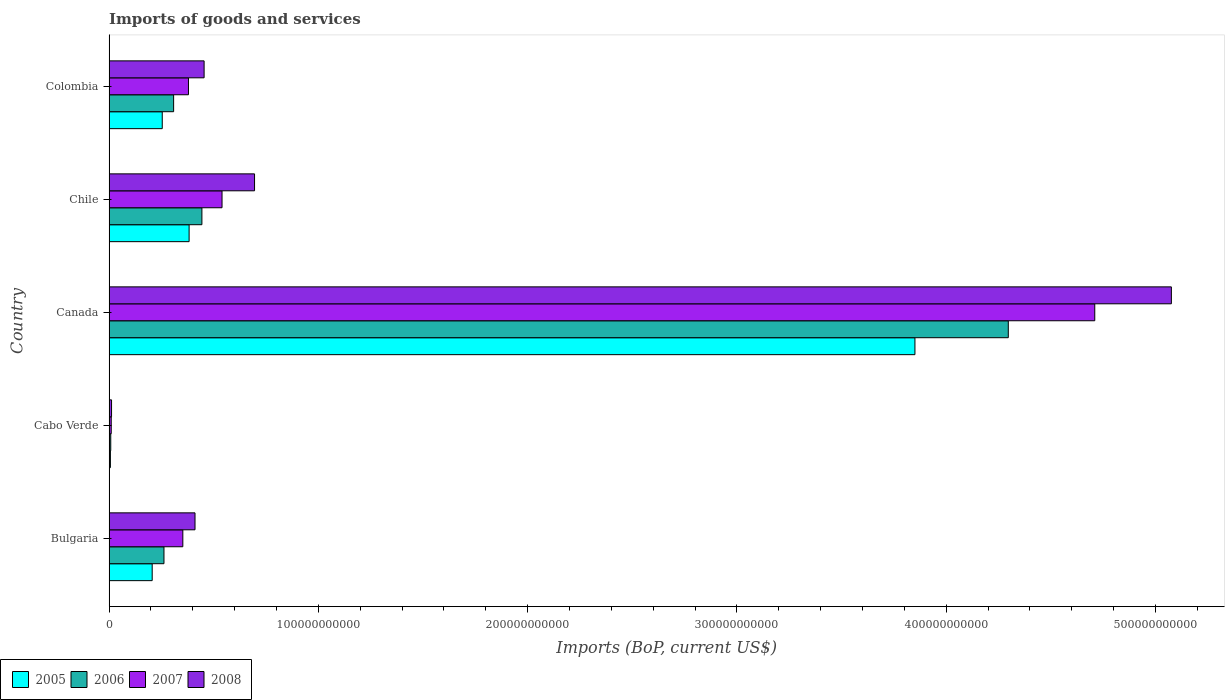How many different coloured bars are there?
Your answer should be compact. 4. How many groups of bars are there?
Your answer should be very brief. 5. Are the number of bars per tick equal to the number of legend labels?
Give a very brief answer. Yes. Are the number of bars on each tick of the Y-axis equal?
Offer a terse response. Yes. What is the label of the 4th group of bars from the top?
Offer a terse response. Cabo Verde. What is the amount spent on imports in 2007 in Canada?
Ensure brevity in your answer.  4.71e+11. Across all countries, what is the maximum amount spent on imports in 2007?
Make the answer very short. 4.71e+11. Across all countries, what is the minimum amount spent on imports in 2006?
Make the answer very short. 8.04e+08. In which country was the amount spent on imports in 2008 maximum?
Your response must be concise. Canada. In which country was the amount spent on imports in 2008 minimum?
Provide a short and direct response. Cabo Verde. What is the total amount spent on imports in 2005 in the graph?
Offer a very short reply. 4.70e+11. What is the difference between the amount spent on imports in 2006 in Bulgaria and that in Cabo Verde?
Your response must be concise. 2.54e+1. What is the difference between the amount spent on imports in 2005 in Cabo Verde and the amount spent on imports in 2007 in Colombia?
Your answer should be compact. -3.73e+1. What is the average amount spent on imports in 2007 per country?
Ensure brevity in your answer.  1.20e+11. What is the difference between the amount spent on imports in 2005 and amount spent on imports in 2007 in Canada?
Your answer should be compact. -8.59e+1. What is the ratio of the amount spent on imports in 2006 in Bulgaria to that in Cabo Verde?
Offer a very short reply. 32.64. Is the amount spent on imports in 2006 in Canada less than that in Colombia?
Keep it short and to the point. No. What is the difference between the highest and the second highest amount spent on imports in 2008?
Provide a short and direct response. 4.38e+11. What is the difference between the highest and the lowest amount spent on imports in 2006?
Give a very brief answer. 4.29e+11. Is the sum of the amount spent on imports in 2007 in Canada and Chile greater than the maximum amount spent on imports in 2008 across all countries?
Your answer should be compact. Yes. Is it the case that in every country, the sum of the amount spent on imports in 2008 and amount spent on imports in 2006 is greater than the sum of amount spent on imports in 2007 and amount spent on imports in 2005?
Ensure brevity in your answer.  No. What does the 2nd bar from the bottom in Bulgaria represents?
Make the answer very short. 2006. Is it the case that in every country, the sum of the amount spent on imports in 2006 and amount spent on imports in 2005 is greater than the amount spent on imports in 2007?
Make the answer very short. Yes. How many bars are there?
Your response must be concise. 20. How many countries are there in the graph?
Give a very brief answer. 5. What is the difference between two consecutive major ticks on the X-axis?
Give a very brief answer. 1.00e+11. Are the values on the major ticks of X-axis written in scientific E-notation?
Ensure brevity in your answer.  No. Does the graph contain any zero values?
Provide a succinct answer. No. Does the graph contain grids?
Ensure brevity in your answer.  No. Where does the legend appear in the graph?
Your answer should be very brief. Bottom left. What is the title of the graph?
Give a very brief answer. Imports of goods and services. What is the label or title of the X-axis?
Provide a short and direct response. Imports (BoP, current US$). What is the Imports (BoP, current US$) in 2005 in Bulgaria?
Offer a very short reply. 2.06e+1. What is the Imports (BoP, current US$) in 2006 in Bulgaria?
Offer a terse response. 2.62e+1. What is the Imports (BoP, current US$) of 2007 in Bulgaria?
Give a very brief answer. 3.52e+1. What is the Imports (BoP, current US$) of 2008 in Bulgaria?
Offer a terse response. 4.11e+1. What is the Imports (BoP, current US$) of 2005 in Cabo Verde?
Your response must be concise. 6.42e+08. What is the Imports (BoP, current US$) in 2006 in Cabo Verde?
Provide a succinct answer. 8.04e+08. What is the Imports (BoP, current US$) of 2007 in Cabo Verde?
Your answer should be very brief. 1.03e+09. What is the Imports (BoP, current US$) of 2008 in Cabo Verde?
Keep it short and to the point. 1.18e+09. What is the Imports (BoP, current US$) in 2005 in Canada?
Your answer should be compact. 3.85e+11. What is the Imports (BoP, current US$) in 2006 in Canada?
Provide a short and direct response. 4.30e+11. What is the Imports (BoP, current US$) in 2007 in Canada?
Your answer should be compact. 4.71e+11. What is the Imports (BoP, current US$) in 2008 in Canada?
Provide a succinct answer. 5.08e+11. What is the Imports (BoP, current US$) in 2005 in Chile?
Provide a succinct answer. 3.82e+1. What is the Imports (BoP, current US$) of 2006 in Chile?
Your answer should be compact. 4.44e+1. What is the Imports (BoP, current US$) of 2007 in Chile?
Give a very brief answer. 5.40e+1. What is the Imports (BoP, current US$) of 2008 in Chile?
Give a very brief answer. 6.95e+1. What is the Imports (BoP, current US$) in 2005 in Colombia?
Ensure brevity in your answer.  2.54e+1. What is the Imports (BoP, current US$) of 2006 in Colombia?
Your response must be concise. 3.09e+1. What is the Imports (BoP, current US$) in 2007 in Colombia?
Offer a very short reply. 3.79e+1. What is the Imports (BoP, current US$) of 2008 in Colombia?
Make the answer very short. 4.54e+1. Across all countries, what is the maximum Imports (BoP, current US$) in 2005?
Keep it short and to the point. 3.85e+11. Across all countries, what is the maximum Imports (BoP, current US$) in 2006?
Provide a succinct answer. 4.30e+11. Across all countries, what is the maximum Imports (BoP, current US$) in 2007?
Your response must be concise. 4.71e+11. Across all countries, what is the maximum Imports (BoP, current US$) in 2008?
Offer a very short reply. 5.08e+11. Across all countries, what is the minimum Imports (BoP, current US$) of 2005?
Your answer should be compact. 6.42e+08. Across all countries, what is the minimum Imports (BoP, current US$) in 2006?
Offer a very short reply. 8.04e+08. Across all countries, what is the minimum Imports (BoP, current US$) of 2007?
Offer a terse response. 1.03e+09. Across all countries, what is the minimum Imports (BoP, current US$) in 2008?
Make the answer very short. 1.18e+09. What is the total Imports (BoP, current US$) in 2005 in the graph?
Make the answer very short. 4.70e+11. What is the total Imports (BoP, current US$) of 2006 in the graph?
Your answer should be compact. 5.32e+11. What is the total Imports (BoP, current US$) in 2007 in the graph?
Offer a terse response. 5.99e+11. What is the total Imports (BoP, current US$) in 2008 in the graph?
Your response must be concise. 6.65e+11. What is the difference between the Imports (BoP, current US$) of 2005 in Bulgaria and that in Cabo Verde?
Offer a terse response. 2.00e+1. What is the difference between the Imports (BoP, current US$) in 2006 in Bulgaria and that in Cabo Verde?
Give a very brief answer. 2.54e+1. What is the difference between the Imports (BoP, current US$) in 2007 in Bulgaria and that in Cabo Verde?
Offer a very short reply. 3.42e+1. What is the difference between the Imports (BoP, current US$) in 2008 in Bulgaria and that in Cabo Verde?
Your response must be concise. 3.99e+1. What is the difference between the Imports (BoP, current US$) in 2005 in Bulgaria and that in Canada?
Your answer should be compact. -3.64e+11. What is the difference between the Imports (BoP, current US$) in 2006 in Bulgaria and that in Canada?
Give a very brief answer. -4.03e+11. What is the difference between the Imports (BoP, current US$) in 2007 in Bulgaria and that in Canada?
Offer a terse response. -4.36e+11. What is the difference between the Imports (BoP, current US$) in 2008 in Bulgaria and that in Canada?
Offer a very short reply. -4.67e+11. What is the difference between the Imports (BoP, current US$) in 2005 in Bulgaria and that in Chile?
Your answer should be very brief. -1.76e+1. What is the difference between the Imports (BoP, current US$) in 2006 in Bulgaria and that in Chile?
Make the answer very short. -1.81e+1. What is the difference between the Imports (BoP, current US$) of 2007 in Bulgaria and that in Chile?
Offer a very short reply. -1.87e+1. What is the difference between the Imports (BoP, current US$) in 2008 in Bulgaria and that in Chile?
Offer a very short reply. -2.85e+1. What is the difference between the Imports (BoP, current US$) in 2005 in Bulgaria and that in Colombia?
Provide a short and direct response. -4.80e+09. What is the difference between the Imports (BoP, current US$) in 2006 in Bulgaria and that in Colombia?
Offer a very short reply. -4.62e+09. What is the difference between the Imports (BoP, current US$) in 2007 in Bulgaria and that in Colombia?
Make the answer very short. -2.70e+09. What is the difference between the Imports (BoP, current US$) of 2008 in Bulgaria and that in Colombia?
Offer a very short reply. -4.35e+09. What is the difference between the Imports (BoP, current US$) in 2005 in Cabo Verde and that in Canada?
Offer a very short reply. -3.84e+11. What is the difference between the Imports (BoP, current US$) in 2006 in Cabo Verde and that in Canada?
Your answer should be very brief. -4.29e+11. What is the difference between the Imports (BoP, current US$) of 2007 in Cabo Verde and that in Canada?
Offer a terse response. -4.70e+11. What is the difference between the Imports (BoP, current US$) of 2008 in Cabo Verde and that in Canada?
Offer a very short reply. -5.06e+11. What is the difference between the Imports (BoP, current US$) in 2005 in Cabo Verde and that in Chile?
Your response must be concise. -3.76e+1. What is the difference between the Imports (BoP, current US$) in 2006 in Cabo Verde and that in Chile?
Keep it short and to the point. -4.36e+1. What is the difference between the Imports (BoP, current US$) of 2007 in Cabo Verde and that in Chile?
Your response must be concise. -5.29e+1. What is the difference between the Imports (BoP, current US$) in 2008 in Cabo Verde and that in Chile?
Give a very brief answer. -6.83e+1. What is the difference between the Imports (BoP, current US$) in 2005 in Cabo Verde and that in Colombia?
Your answer should be compact. -2.48e+1. What is the difference between the Imports (BoP, current US$) in 2006 in Cabo Verde and that in Colombia?
Offer a very short reply. -3.00e+1. What is the difference between the Imports (BoP, current US$) of 2007 in Cabo Verde and that in Colombia?
Keep it short and to the point. -3.69e+1. What is the difference between the Imports (BoP, current US$) in 2008 in Cabo Verde and that in Colombia?
Your answer should be compact. -4.42e+1. What is the difference between the Imports (BoP, current US$) of 2005 in Canada and that in Chile?
Give a very brief answer. 3.47e+11. What is the difference between the Imports (BoP, current US$) of 2006 in Canada and that in Chile?
Provide a succinct answer. 3.85e+11. What is the difference between the Imports (BoP, current US$) in 2007 in Canada and that in Chile?
Ensure brevity in your answer.  4.17e+11. What is the difference between the Imports (BoP, current US$) in 2008 in Canada and that in Chile?
Keep it short and to the point. 4.38e+11. What is the difference between the Imports (BoP, current US$) of 2005 in Canada and that in Colombia?
Give a very brief answer. 3.60e+11. What is the difference between the Imports (BoP, current US$) of 2006 in Canada and that in Colombia?
Provide a short and direct response. 3.99e+11. What is the difference between the Imports (BoP, current US$) of 2007 in Canada and that in Colombia?
Ensure brevity in your answer.  4.33e+11. What is the difference between the Imports (BoP, current US$) in 2008 in Canada and that in Colombia?
Ensure brevity in your answer.  4.62e+11. What is the difference between the Imports (BoP, current US$) of 2005 in Chile and that in Colombia?
Give a very brief answer. 1.28e+1. What is the difference between the Imports (BoP, current US$) in 2006 in Chile and that in Colombia?
Offer a terse response. 1.35e+1. What is the difference between the Imports (BoP, current US$) in 2007 in Chile and that in Colombia?
Provide a short and direct response. 1.60e+1. What is the difference between the Imports (BoP, current US$) of 2008 in Chile and that in Colombia?
Make the answer very short. 2.41e+1. What is the difference between the Imports (BoP, current US$) in 2005 in Bulgaria and the Imports (BoP, current US$) in 2006 in Cabo Verde?
Your answer should be compact. 1.98e+1. What is the difference between the Imports (BoP, current US$) of 2005 in Bulgaria and the Imports (BoP, current US$) of 2007 in Cabo Verde?
Your answer should be compact. 1.96e+1. What is the difference between the Imports (BoP, current US$) in 2005 in Bulgaria and the Imports (BoP, current US$) in 2008 in Cabo Verde?
Your answer should be very brief. 1.94e+1. What is the difference between the Imports (BoP, current US$) of 2006 in Bulgaria and the Imports (BoP, current US$) of 2007 in Cabo Verde?
Make the answer very short. 2.52e+1. What is the difference between the Imports (BoP, current US$) of 2006 in Bulgaria and the Imports (BoP, current US$) of 2008 in Cabo Verde?
Provide a short and direct response. 2.51e+1. What is the difference between the Imports (BoP, current US$) in 2007 in Bulgaria and the Imports (BoP, current US$) in 2008 in Cabo Verde?
Offer a very short reply. 3.41e+1. What is the difference between the Imports (BoP, current US$) in 2005 in Bulgaria and the Imports (BoP, current US$) in 2006 in Canada?
Make the answer very short. -4.09e+11. What is the difference between the Imports (BoP, current US$) of 2005 in Bulgaria and the Imports (BoP, current US$) of 2007 in Canada?
Your response must be concise. -4.50e+11. What is the difference between the Imports (BoP, current US$) of 2005 in Bulgaria and the Imports (BoP, current US$) of 2008 in Canada?
Make the answer very short. -4.87e+11. What is the difference between the Imports (BoP, current US$) of 2006 in Bulgaria and the Imports (BoP, current US$) of 2007 in Canada?
Make the answer very short. -4.45e+11. What is the difference between the Imports (BoP, current US$) in 2006 in Bulgaria and the Imports (BoP, current US$) in 2008 in Canada?
Provide a succinct answer. -4.81e+11. What is the difference between the Imports (BoP, current US$) of 2007 in Bulgaria and the Imports (BoP, current US$) of 2008 in Canada?
Ensure brevity in your answer.  -4.72e+11. What is the difference between the Imports (BoP, current US$) of 2005 in Bulgaria and the Imports (BoP, current US$) of 2006 in Chile?
Offer a very short reply. -2.38e+1. What is the difference between the Imports (BoP, current US$) of 2005 in Bulgaria and the Imports (BoP, current US$) of 2007 in Chile?
Offer a very short reply. -3.34e+1. What is the difference between the Imports (BoP, current US$) in 2005 in Bulgaria and the Imports (BoP, current US$) in 2008 in Chile?
Keep it short and to the point. -4.89e+1. What is the difference between the Imports (BoP, current US$) in 2006 in Bulgaria and the Imports (BoP, current US$) in 2007 in Chile?
Your answer should be compact. -2.77e+1. What is the difference between the Imports (BoP, current US$) in 2006 in Bulgaria and the Imports (BoP, current US$) in 2008 in Chile?
Keep it short and to the point. -4.33e+1. What is the difference between the Imports (BoP, current US$) in 2007 in Bulgaria and the Imports (BoP, current US$) in 2008 in Chile?
Your answer should be very brief. -3.43e+1. What is the difference between the Imports (BoP, current US$) in 2005 in Bulgaria and the Imports (BoP, current US$) in 2006 in Colombia?
Provide a succinct answer. -1.02e+1. What is the difference between the Imports (BoP, current US$) in 2005 in Bulgaria and the Imports (BoP, current US$) in 2007 in Colombia?
Ensure brevity in your answer.  -1.73e+1. What is the difference between the Imports (BoP, current US$) in 2005 in Bulgaria and the Imports (BoP, current US$) in 2008 in Colombia?
Make the answer very short. -2.48e+1. What is the difference between the Imports (BoP, current US$) of 2006 in Bulgaria and the Imports (BoP, current US$) of 2007 in Colombia?
Offer a terse response. -1.17e+1. What is the difference between the Imports (BoP, current US$) of 2006 in Bulgaria and the Imports (BoP, current US$) of 2008 in Colombia?
Offer a terse response. -1.92e+1. What is the difference between the Imports (BoP, current US$) in 2007 in Bulgaria and the Imports (BoP, current US$) in 2008 in Colombia?
Your answer should be compact. -1.02e+1. What is the difference between the Imports (BoP, current US$) in 2005 in Cabo Verde and the Imports (BoP, current US$) in 2006 in Canada?
Your answer should be compact. -4.29e+11. What is the difference between the Imports (BoP, current US$) in 2005 in Cabo Verde and the Imports (BoP, current US$) in 2007 in Canada?
Ensure brevity in your answer.  -4.70e+11. What is the difference between the Imports (BoP, current US$) in 2005 in Cabo Verde and the Imports (BoP, current US$) in 2008 in Canada?
Give a very brief answer. -5.07e+11. What is the difference between the Imports (BoP, current US$) of 2006 in Cabo Verde and the Imports (BoP, current US$) of 2007 in Canada?
Make the answer very short. -4.70e+11. What is the difference between the Imports (BoP, current US$) of 2006 in Cabo Verde and the Imports (BoP, current US$) of 2008 in Canada?
Provide a short and direct response. -5.07e+11. What is the difference between the Imports (BoP, current US$) in 2007 in Cabo Verde and the Imports (BoP, current US$) in 2008 in Canada?
Your answer should be compact. -5.07e+11. What is the difference between the Imports (BoP, current US$) of 2005 in Cabo Verde and the Imports (BoP, current US$) of 2006 in Chile?
Ensure brevity in your answer.  -4.37e+1. What is the difference between the Imports (BoP, current US$) in 2005 in Cabo Verde and the Imports (BoP, current US$) in 2007 in Chile?
Offer a very short reply. -5.33e+1. What is the difference between the Imports (BoP, current US$) of 2005 in Cabo Verde and the Imports (BoP, current US$) of 2008 in Chile?
Offer a terse response. -6.89e+1. What is the difference between the Imports (BoP, current US$) of 2006 in Cabo Verde and the Imports (BoP, current US$) of 2007 in Chile?
Your answer should be compact. -5.32e+1. What is the difference between the Imports (BoP, current US$) in 2006 in Cabo Verde and the Imports (BoP, current US$) in 2008 in Chile?
Provide a short and direct response. -6.87e+1. What is the difference between the Imports (BoP, current US$) in 2007 in Cabo Verde and the Imports (BoP, current US$) in 2008 in Chile?
Keep it short and to the point. -6.85e+1. What is the difference between the Imports (BoP, current US$) in 2005 in Cabo Verde and the Imports (BoP, current US$) in 2006 in Colombia?
Provide a succinct answer. -3.02e+1. What is the difference between the Imports (BoP, current US$) in 2005 in Cabo Verde and the Imports (BoP, current US$) in 2007 in Colombia?
Offer a terse response. -3.73e+1. What is the difference between the Imports (BoP, current US$) of 2005 in Cabo Verde and the Imports (BoP, current US$) of 2008 in Colombia?
Provide a succinct answer. -4.48e+1. What is the difference between the Imports (BoP, current US$) of 2006 in Cabo Verde and the Imports (BoP, current US$) of 2007 in Colombia?
Your answer should be compact. -3.71e+1. What is the difference between the Imports (BoP, current US$) in 2006 in Cabo Verde and the Imports (BoP, current US$) in 2008 in Colombia?
Give a very brief answer. -4.46e+1. What is the difference between the Imports (BoP, current US$) in 2007 in Cabo Verde and the Imports (BoP, current US$) in 2008 in Colombia?
Offer a terse response. -4.44e+1. What is the difference between the Imports (BoP, current US$) in 2005 in Canada and the Imports (BoP, current US$) in 2006 in Chile?
Give a very brief answer. 3.41e+11. What is the difference between the Imports (BoP, current US$) of 2005 in Canada and the Imports (BoP, current US$) of 2007 in Chile?
Your answer should be compact. 3.31e+11. What is the difference between the Imports (BoP, current US$) of 2005 in Canada and the Imports (BoP, current US$) of 2008 in Chile?
Keep it short and to the point. 3.16e+11. What is the difference between the Imports (BoP, current US$) in 2006 in Canada and the Imports (BoP, current US$) in 2007 in Chile?
Offer a very short reply. 3.76e+11. What is the difference between the Imports (BoP, current US$) in 2006 in Canada and the Imports (BoP, current US$) in 2008 in Chile?
Your answer should be very brief. 3.60e+11. What is the difference between the Imports (BoP, current US$) in 2007 in Canada and the Imports (BoP, current US$) in 2008 in Chile?
Offer a terse response. 4.01e+11. What is the difference between the Imports (BoP, current US$) of 2005 in Canada and the Imports (BoP, current US$) of 2006 in Colombia?
Give a very brief answer. 3.54e+11. What is the difference between the Imports (BoP, current US$) of 2005 in Canada and the Imports (BoP, current US$) of 2007 in Colombia?
Offer a very short reply. 3.47e+11. What is the difference between the Imports (BoP, current US$) of 2005 in Canada and the Imports (BoP, current US$) of 2008 in Colombia?
Offer a terse response. 3.40e+11. What is the difference between the Imports (BoP, current US$) in 2006 in Canada and the Imports (BoP, current US$) in 2007 in Colombia?
Provide a short and direct response. 3.92e+11. What is the difference between the Imports (BoP, current US$) in 2006 in Canada and the Imports (BoP, current US$) in 2008 in Colombia?
Provide a short and direct response. 3.84e+11. What is the difference between the Imports (BoP, current US$) of 2007 in Canada and the Imports (BoP, current US$) of 2008 in Colombia?
Make the answer very short. 4.26e+11. What is the difference between the Imports (BoP, current US$) of 2005 in Chile and the Imports (BoP, current US$) of 2006 in Colombia?
Keep it short and to the point. 7.40e+09. What is the difference between the Imports (BoP, current US$) in 2005 in Chile and the Imports (BoP, current US$) in 2007 in Colombia?
Make the answer very short. 3.07e+08. What is the difference between the Imports (BoP, current US$) of 2005 in Chile and the Imports (BoP, current US$) of 2008 in Colombia?
Give a very brief answer. -7.17e+09. What is the difference between the Imports (BoP, current US$) in 2006 in Chile and the Imports (BoP, current US$) in 2007 in Colombia?
Provide a succinct answer. 6.42e+09. What is the difference between the Imports (BoP, current US$) in 2006 in Chile and the Imports (BoP, current US$) in 2008 in Colombia?
Give a very brief answer. -1.05e+09. What is the difference between the Imports (BoP, current US$) of 2007 in Chile and the Imports (BoP, current US$) of 2008 in Colombia?
Your response must be concise. 8.57e+09. What is the average Imports (BoP, current US$) in 2005 per country?
Provide a short and direct response. 9.40e+1. What is the average Imports (BoP, current US$) of 2006 per country?
Ensure brevity in your answer.  1.06e+11. What is the average Imports (BoP, current US$) of 2007 per country?
Keep it short and to the point. 1.20e+11. What is the average Imports (BoP, current US$) of 2008 per country?
Keep it short and to the point. 1.33e+11. What is the difference between the Imports (BoP, current US$) in 2005 and Imports (BoP, current US$) in 2006 in Bulgaria?
Make the answer very short. -5.63e+09. What is the difference between the Imports (BoP, current US$) of 2005 and Imports (BoP, current US$) of 2007 in Bulgaria?
Offer a very short reply. -1.46e+1. What is the difference between the Imports (BoP, current US$) in 2005 and Imports (BoP, current US$) in 2008 in Bulgaria?
Keep it short and to the point. -2.05e+1. What is the difference between the Imports (BoP, current US$) in 2006 and Imports (BoP, current US$) in 2007 in Bulgaria?
Ensure brevity in your answer.  -9.01e+09. What is the difference between the Imports (BoP, current US$) of 2006 and Imports (BoP, current US$) of 2008 in Bulgaria?
Offer a very short reply. -1.48e+1. What is the difference between the Imports (BoP, current US$) in 2007 and Imports (BoP, current US$) in 2008 in Bulgaria?
Make the answer very short. -5.82e+09. What is the difference between the Imports (BoP, current US$) in 2005 and Imports (BoP, current US$) in 2006 in Cabo Verde?
Your response must be concise. -1.62e+08. What is the difference between the Imports (BoP, current US$) in 2005 and Imports (BoP, current US$) in 2007 in Cabo Verde?
Keep it short and to the point. -3.92e+08. What is the difference between the Imports (BoP, current US$) of 2005 and Imports (BoP, current US$) of 2008 in Cabo Verde?
Your answer should be very brief. -5.41e+08. What is the difference between the Imports (BoP, current US$) of 2006 and Imports (BoP, current US$) of 2007 in Cabo Verde?
Offer a very short reply. -2.30e+08. What is the difference between the Imports (BoP, current US$) of 2006 and Imports (BoP, current US$) of 2008 in Cabo Verde?
Your answer should be very brief. -3.79e+08. What is the difference between the Imports (BoP, current US$) in 2007 and Imports (BoP, current US$) in 2008 in Cabo Verde?
Offer a very short reply. -1.50e+08. What is the difference between the Imports (BoP, current US$) in 2005 and Imports (BoP, current US$) in 2006 in Canada?
Provide a short and direct response. -4.46e+1. What is the difference between the Imports (BoP, current US$) in 2005 and Imports (BoP, current US$) in 2007 in Canada?
Provide a short and direct response. -8.59e+1. What is the difference between the Imports (BoP, current US$) in 2005 and Imports (BoP, current US$) in 2008 in Canada?
Keep it short and to the point. -1.23e+11. What is the difference between the Imports (BoP, current US$) in 2006 and Imports (BoP, current US$) in 2007 in Canada?
Your response must be concise. -4.13e+1. What is the difference between the Imports (BoP, current US$) of 2006 and Imports (BoP, current US$) of 2008 in Canada?
Offer a very short reply. -7.79e+1. What is the difference between the Imports (BoP, current US$) of 2007 and Imports (BoP, current US$) of 2008 in Canada?
Your response must be concise. -3.66e+1. What is the difference between the Imports (BoP, current US$) of 2005 and Imports (BoP, current US$) of 2006 in Chile?
Keep it short and to the point. -6.11e+09. What is the difference between the Imports (BoP, current US$) of 2005 and Imports (BoP, current US$) of 2007 in Chile?
Keep it short and to the point. -1.57e+1. What is the difference between the Imports (BoP, current US$) of 2005 and Imports (BoP, current US$) of 2008 in Chile?
Keep it short and to the point. -3.13e+1. What is the difference between the Imports (BoP, current US$) of 2006 and Imports (BoP, current US$) of 2007 in Chile?
Offer a very short reply. -9.62e+09. What is the difference between the Imports (BoP, current US$) in 2006 and Imports (BoP, current US$) in 2008 in Chile?
Your answer should be compact. -2.52e+1. What is the difference between the Imports (BoP, current US$) of 2007 and Imports (BoP, current US$) of 2008 in Chile?
Offer a very short reply. -1.55e+1. What is the difference between the Imports (BoP, current US$) in 2005 and Imports (BoP, current US$) in 2006 in Colombia?
Your answer should be compact. -5.44e+09. What is the difference between the Imports (BoP, current US$) of 2005 and Imports (BoP, current US$) of 2007 in Colombia?
Offer a terse response. -1.25e+1. What is the difference between the Imports (BoP, current US$) in 2005 and Imports (BoP, current US$) in 2008 in Colombia?
Offer a terse response. -2.00e+1. What is the difference between the Imports (BoP, current US$) in 2006 and Imports (BoP, current US$) in 2007 in Colombia?
Your answer should be compact. -7.09e+09. What is the difference between the Imports (BoP, current US$) of 2006 and Imports (BoP, current US$) of 2008 in Colombia?
Your response must be concise. -1.46e+1. What is the difference between the Imports (BoP, current US$) of 2007 and Imports (BoP, current US$) of 2008 in Colombia?
Offer a very short reply. -7.47e+09. What is the ratio of the Imports (BoP, current US$) of 2005 in Bulgaria to that in Cabo Verde?
Make the answer very short. 32.11. What is the ratio of the Imports (BoP, current US$) of 2006 in Bulgaria to that in Cabo Verde?
Offer a very short reply. 32.64. What is the ratio of the Imports (BoP, current US$) of 2007 in Bulgaria to that in Cabo Verde?
Your answer should be compact. 34.1. What is the ratio of the Imports (BoP, current US$) in 2008 in Bulgaria to that in Cabo Verde?
Your answer should be compact. 34.71. What is the ratio of the Imports (BoP, current US$) of 2005 in Bulgaria to that in Canada?
Provide a succinct answer. 0.05. What is the ratio of the Imports (BoP, current US$) in 2006 in Bulgaria to that in Canada?
Your answer should be very brief. 0.06. What is the ratio of the Imports (BoP, current US$) in 2007 in Bulgaria to that in Canada?
Provide a short and direct response. 0.07. What is the ratio of the Imports (BoP, current US$) of 2008 in Bulgaria to that in Canada?
Offer a very short reply. 0.08. What is the ratio of the Imports (BoP, current US$) of 2005 in Bulgaria to that in Chile?
Your answer should be very brief. 0.54. What is the ratio of the Imports (BoP, current US$) in 2006 in Bulgaria to that in Chile?
Offer a very short reply. 0.59. What is the ratio of the Imports (BoP, current US$) of 2007 in Bulgaria to that in Chile?
Offer a terse response. 0.65. What is the ratio of the Imports (BoP, current US$) in 2008 in Bulgaria to that in Chile?
Provide a short and direct response. 0.59. What is the ratio of the Imports (BoP, current US$) of 2005 in Bulgaria to that in Colombia?
Your response must be concise. 0.81. What is the ratio of the Imports (BoP, current US$) in 2006 in Bulgaria to that in Colombia?
Your answer should be very brief. 0.85. What is the ratio of the Imports (BoP, current US$) of 2007 in Bulgaria to that in Colombia?
Your answer should be compact. 0.93. What is the ratio of the Imports (BoP, current US$) in 2008 in Bulgaria to that in Colombia?
Offer a terse response. 0.9. What is the ratio of the Imports (BoP, current US$) of 2005 in Cabo Verde to that in Canada?
Keep it short and to the point. 0. What is the ratio of the Imports (BoP, current US$) of 2006 in Cabo Verde to that in Canada?
Your response must be concise. 0. What is the ratio of the Imports (BoP, current US$) in 2007 in Cabo Verde to that in Canada?
Offer a very short reply. 0. What is the ratio of the Imports (BoP, current US$) of 2008 in Cabo Verde to that in Canada?
Provide a short and direct response. 0. What is the ratio of the Imports (BoP, current US$) in 2005 in Cabo Verde to that in Chile?
Ensure brevity in your answer.  0.02. What is the ratio of the Imports (BoP, current US$) of 2006 in Cabo Verde to that in Chile?
Provide a short and direct response. 0.02. What is the ratio of the Imports (BoP, current US$) of 2007 in Cabo Verde to that in Chile?
Ensure brevity in your answer.  0.02. What is the ratio of the Imports (BoP, current US$) of 2008 in Cabo Verde to that in Chile?
Offer a terse response. 0.02. What is the ratio of the Imports (BoP, current US$) of 2005 in Cabo Verde to that in Colombia?
Offer a terse response. 0.03. What is the ratio of the Imports (BoP, current US$) of 2006 in Cabo Verde to that in Colombia?
Provide a short and direct response. 0.03. What is the ratio of the Imports (BoP, current US$) of 2007 in Cabo Verde to that in Colombia?
Offer a terse response. 0.03. What is the ratio of the Imports (BoP, current US$) of 2008 in Cabo Verde to that in Colombia?
Make the answer very short. 0.03. What is the ratio of the Imports (BoP, current US$) in 2005 in Canada to that in Chile?
Provide a succinct answer. 10.07. What is the ratio of the Imports (BoP, current US$) of 2006 in Canada to that in Chile?
Your answer should be compact. 9.69. What is the ratio of the Imports (BoP, current US$) in 2007 in Canada to that in Chile?
Ensure brevity in your answer.  8.73. What is the ratio of the Imports (BoP, current US$) of 2008 in Canada to that in Chile?
Offer a very short reply. 7.3. What is the ratio of the Imports (BoP, current US$) in 2005 in Canada to that in Colombia?
Your answer should be very brief. 15.15. What is the ratio of the Imports (BoP, current US$) of 2006 in Canada to that in Colombia?
Give a very brief answer. 13.93. What is the ratio of the Imports (BoP, current US$) in 2007 in Canada to that in Colombia?
Provide a succinct answer. 12.41. What is the ratio of the Imports (BoP, current US$) of 2008 in Canada to that in Colombia?
Make the answer very short. 11.18. What is the ratio of the Imports (BoP, current US$) in 2005 in Chile to that in Colombia?
Offer a terse response. 1.51. What is the ratio of the Imports (BoP, current US$) in 2006 in Chile to that in Colombia?
Your answer should be compact. 1.44. What is the ratio of the Imports (BoP, current US$) of 2007 in Chile to that in Colombia?
Your answer should be very brief. 1.42. What is the ratio of the Imports (BoP, current US$) in 2008 in Chile to that in Colombia?
Your answer should be very brief. 1.53. What is the difference between the highest and the second highest Imports (BoP, current US$) in 2005?
Your answer should be very brief. 3.47e+11. What is the difference between the highest and the second highest Imports (BoP, current US$) of 2006?
Your answer should be very brief. 3.85e+11. What is the difference between the highest and the second highest Imports (BoP, current US$) of 2007?
Ensure brevity in your answer.  4.17e+11. What is the difference between the highest and the second highest Imports (BoP, current US$) in 2008?
Offer a terse response. 4.38e+11. What is the difference between the highest and the lowest Imports (BoP, current US$) of 2005?
Make the answer very short. 3.84e+11. What is the difference between the highest and the lowest Imports (BoP, current US$) in 2006?
Offer a very short reply. 4.29e+11. What is the difference between the highest and the lowest Imports (BoP, current US$) in 2007?
Offer a terse response. 4.70e+11. What is the difference between the highest and the lowest Imports (BoP, current US$) of 2008?
Your answer should be very brief. 5.06e+11. 